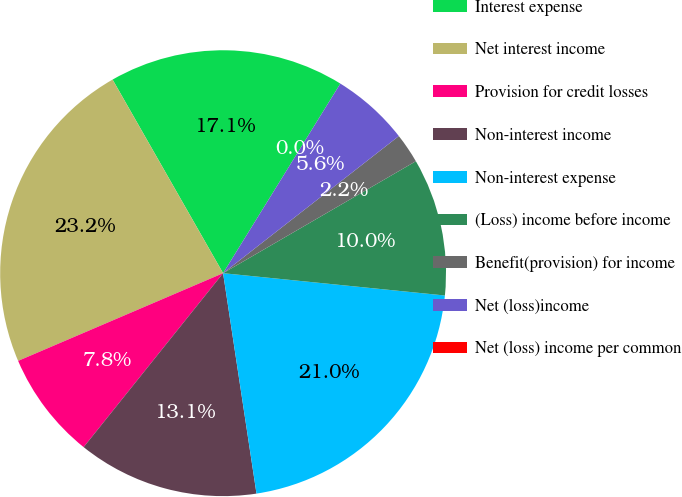<chart> <loc_0><loc_0><loc_500><loc_500><pie_chart><fcel>Interest expense<fcel>Net interest income<fcel>Provision for credit losses<fcel>Non-interest income<fcel>Non-interest expense<fcel>(Loss) income before income<fcel>Benefit(provision) for income<fcel>Net (loss)income<fcel>Net (loss) income per common<nl><fcel>17.07%<fcel>23.18%<fcel>7.81%<fcel>13.15%<fcel>21.01%<fcel>9.97%<fcel>2.17%<fcel>5.64%<fcel>0.0%<nl></chart> 